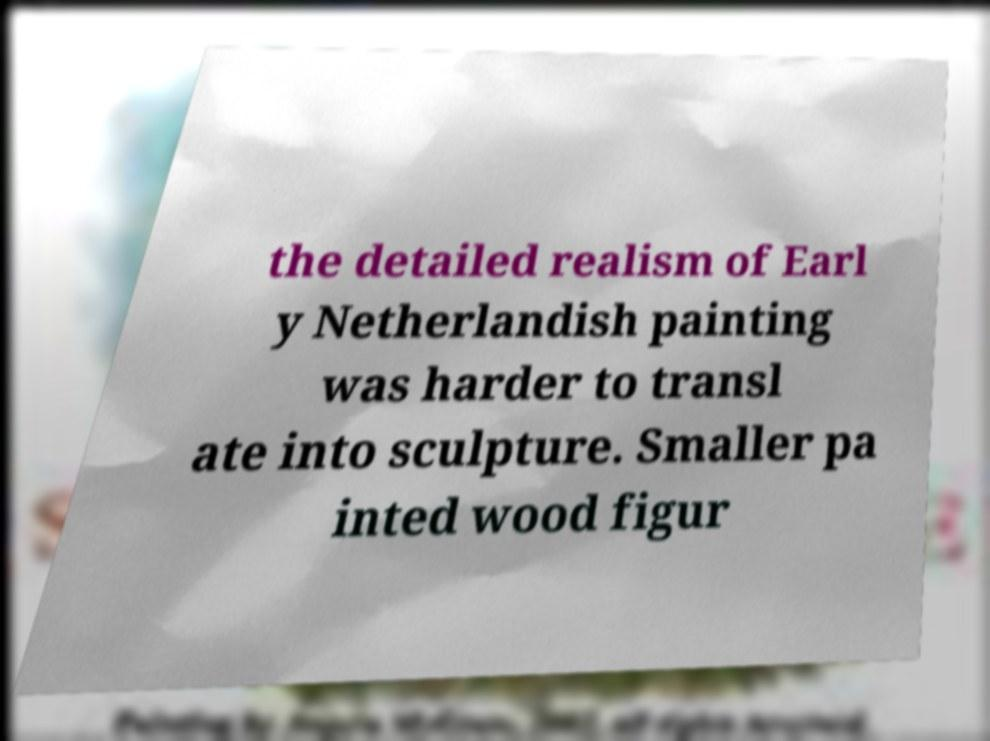Please read and relay the text visible in this image. What does it say? the detailed realism of Earl y Netherlandish painting was harder to transl ate into sculpture. Smaller pa inted wood figur 